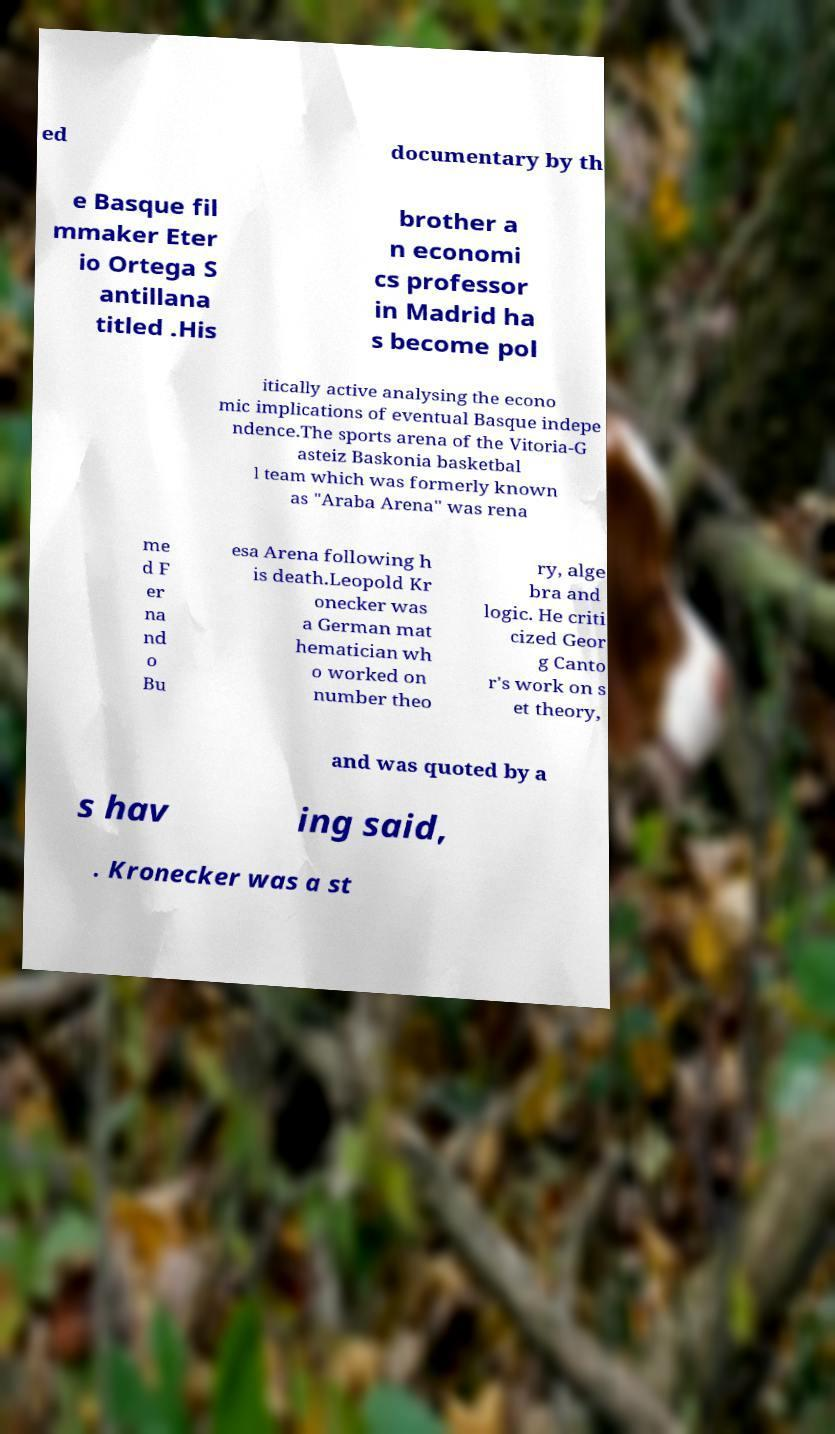What messages or text are displayed in this image? I need them in a readable, typed format. ed documentary by th e Basque fil mmaker Eter io Ortega S antillana titled .His brother a n economi cs professor in Madrid ha s become pol itically active analysing the econo mic implications of eventual Basque indepe ndence.The sports arena of the Vitoria-G asteiz Baskonia basketbal l team which was formerly known as "Araba Arena" was rena me d F er na nd o Bu esa Arena following h is death.Leopold Kr onecker was a German mat hematician wh o worked on number theo ry, alge bra and logic. He criti cized Geor g Canto r's work on s et theory, and was quoted by a s hav ing said, . Kronecker was a st 